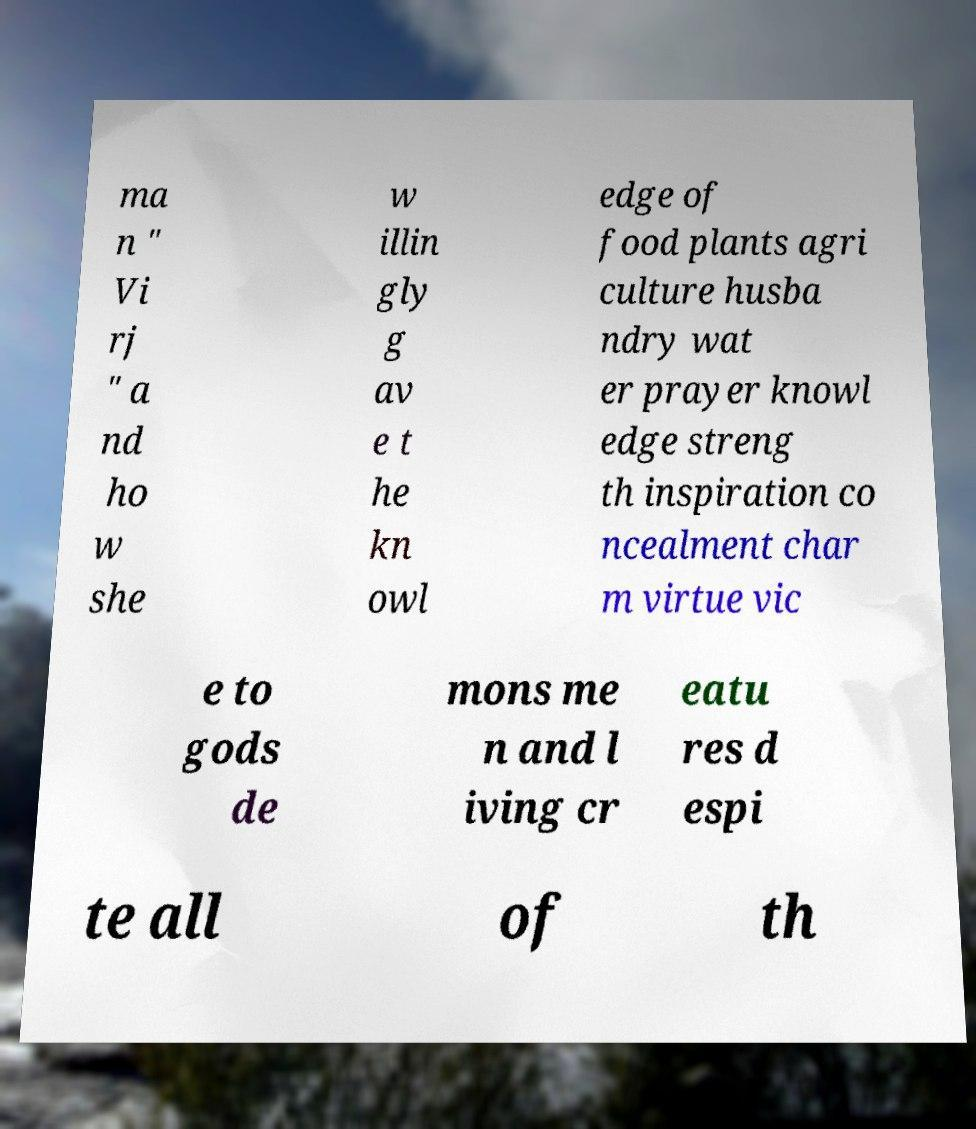Could you assist in decoding the text presented in this image and type it out clearly? ma n " Vi rj " a nd ho w she w illin gly g av e t he kn owl edge of food plants agri culture husba ndry wat er prayer knowl edge streng th inspiration co ncealment char m virtue vic e to gods de mons me n and l iving cr eatu res d espi te all of th 